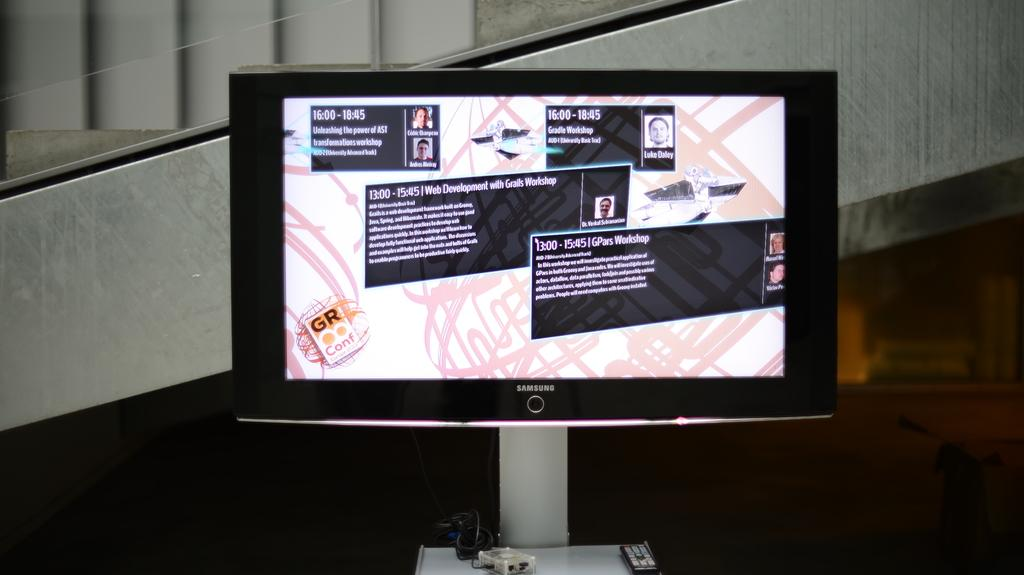<image>
Render a clear and concise summary of the photo. A bunch of signs on a monitor including one that reads 13:00-15:45 | GPars Workshop. 